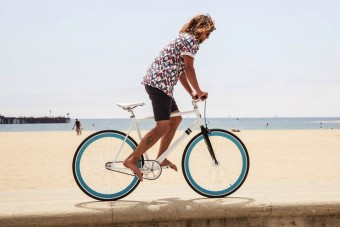Describe the weather conditions in this image. The weather appears to be clear and sunny, with no visible clouds, which suggests a pleasant and mild climate, ideal for outdoor activities like cycling. 